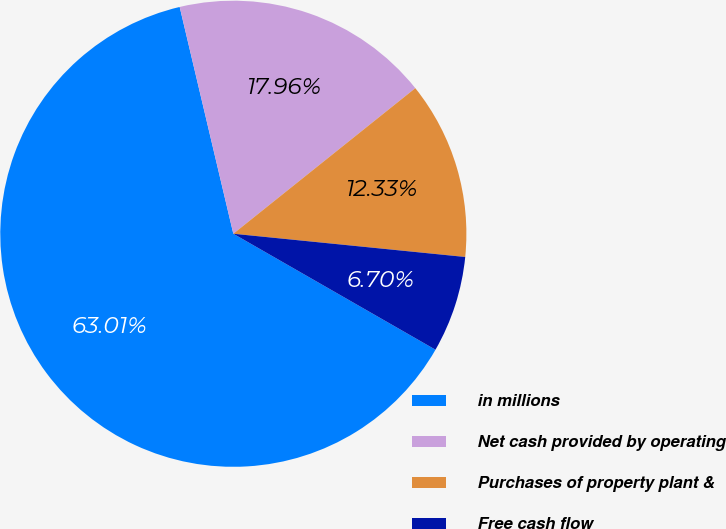Convert chart to OTSL. <chart><loc_0><loc_0><loc_500><loc_500><pie_chart><fcel>in millions<fcel>Net cash provided by operating<fcel>Purchases of property plant &<fcel>Free cash flow<nl><fcel>63.02%<fcel>17.96%<fcel>12.33%<fcel>6.7%<nl></chart> 